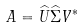Convert formula to latex. <formula><loc_0><loc_0><loc_500><loc_500>A = { \widehat { U } } { \widehat { \Sigma } } V ^ { \ast }</formula> 